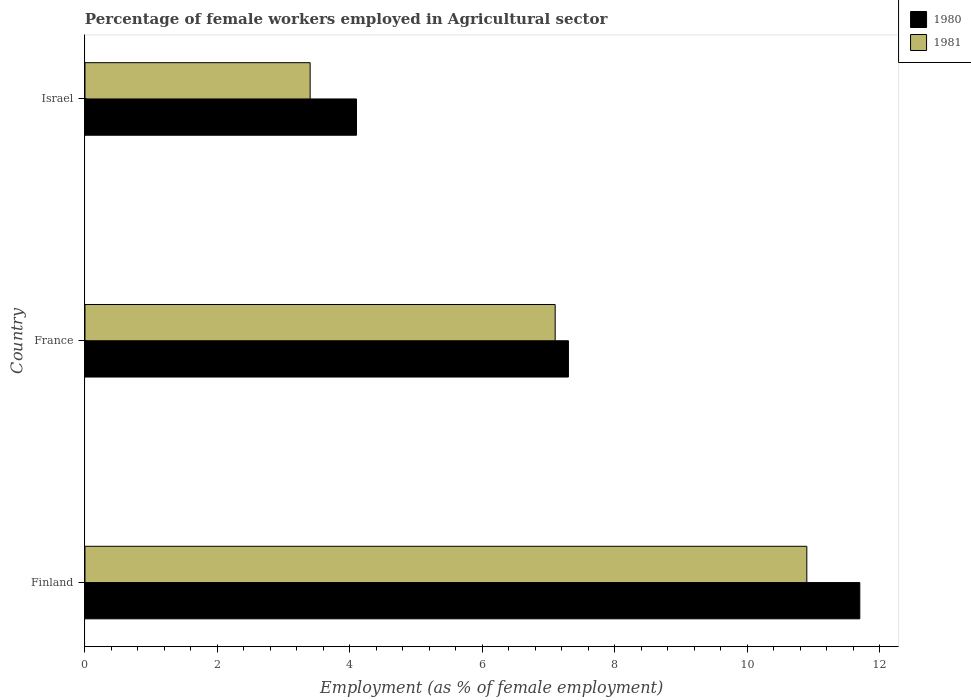How many different coloured bars are there?
Provide a succinct answer. 2. Are the number of bars per tick equal to the number of legend labels?
Your response must be concise. Yes. Are the number of bars on each tick of the Y-axis equal?
Your response must be concise. Yes. How many bars are there on the 1st tick from the bottom?
Offer a very short reply. 2. What is the label of the 3rd group of bars from the top?
Your answer should be very brief. Finland. What is the percentage of females employed in Agricultural sector in 1980 in Israel?
Your answer should be very brief. 4.1. Across all countries, what is the maximum percentage of females employed in Agricultural sector in 1981?
Provide a short and direct response. 10.9. Across all countries, what is the minimum percentage of females employed in Agricultural sector in 1980?
Make the answer very short. 4.1. In which country was the percentage of females employed in Agricultural sector in 1980 minimum?
Ensure brevity in your answer.  Israel. What is the total percentage of females employed in Agricultural sector in 1980 in the graph?
Your response must be concise. 23.1. What is the difference between the percentage of females employed in Agricultural sector in 1981 in France and that in Israel?
Your answer should be very brief. 3.7. What is the difference between the percentage of females employed in Agricultural sector in 1980 in Finland and the percentage of females employed in Agricultural sector in 1981 in Israel?
Your response must be concise. 8.3. What is the average percentage of females employed in Agricultural sector in 1980 per country?
Offer a very short reply. 7.7. What is the difference between the percentage of females employed in Agricultural sector in 1980 and percentage of females employed in Agricultural sector in 1981 in Finland?
Offer a very short reply. 0.8. In how many countries, is the percentage of females employed in Agricultural sector in 1980 greater than 10 %?
Give a very brief answer. 1. What is the ratio of the percentage of females employed in Agricultural sector in 1981 in Finland to that in France?
Your answer should be compact. 1.54. Is the difference between the percentage of females employed in Agricultural sector in 1980 in France and Israel greater than the difference between the percentage of females employed in Agricultural sector in 1981 in France and Israel?
Make the answer very short. No. What is the difference between the highest and the second highest percentage of females employed in Agricultural sector in 1981?
Offer a terse response. 3.8. What is the difference between the highest and the lowest percentage of females employed in Agricultural sector in 1981?
Your response must be concise. 7.5. What does the 1st bar from the top in Israel represents?
Offer a terse response. 1981. What does the 1st bar from the bottom in Israel represents?
Ensure brevity in your answer.  1980. How many countries are there in the graph?
Your answer should be compact. 3. Are the values on the major ticks of X-axis written in scientific E-notation?
Provide a short and direct response. No. Where does the legend appear in the graph?
Ensure brevity in your answer.  Top right. How many legend labels are there?
Offer a terse response. 2. What is the title of the graph?
Provide a short and direct response. Percentage of female workers employed in Agricultural sector. Does "1996" appear as one of the legend labels in the graph?
Your answer should be very brief. No. What is the label or title of the X-axis?
Your response must be concise. Employment (as % of female employment). What is the Employment (as % of female employment) of 1980 in Finland?
Your answer should be very brief. 11.7. What is the Employment (as % of female employment) in 1981 in Finland?
Offer a terse response. 10.9. What is the Employment (as % of female employment) in 1980 in France?
Provide a succinct answer. 7.3. What is the Employment (as % of female employment) in 1981 in France?
Your answer should be very brief. 7.1. What is the Employment (as % of female employment) in 1980 in Israel?
Make the answer very short. 4.1. What is the Employment (as % of female employment) in 1981 in Israel?
Give a very brief answer. 3.4. Across all countries, what is the maximum Employment (as % of female employment) in 1980?
Your answer should be very brief. 11.7. Across all countries, what is the maximum Employment (as % of female employment) of 1981?
Your response must be concise. 10.9. Across all countries, what is the minimum Employment (as % of female employment) in 1980?
Offer a very short reply. 4.1. Across all countries, what is the minimum Employment (as % of female employment) of 1981?
Provide a short and direct response. 3.4. What is the total Employment (as % of female employment) of 1980 in the graph?
Provide a short and direct response. 23.1. What is the total Employment (as % of female employment) of 1981 in the graph?
Offer a terse response. 21.4. What is the difference between the Employment (as % of female employment) of 1981 in France and that in Israel?
Offer a very short reply. 3.7. What is the difference between the Employment (as % of female employment) in 1980 in Finland and the Employment (as % of female employment) in 1981 in France?
Keep it short and to the point. 4.6. What is the difference between the Employment (as % of female employment) in 1980 in Finland and the Employment (as % of female employment) in 1981 in Israel?
Ensure brevity in your answer.  8.3. What is the average Employment (as % of female employment) in 1981 per country?
Provide a short and direct response. 7.13. What is the ratio of the Employment (as % of female employment) in 1980 in Finland to that in France?
Offer a terse response. 1.6. What is the ratio of the Employment (as % of female employment) in 1981 in Finland to that in France?
Your answer should be very brief. 1.54. What is the ratio of the Employment (as % of female employment) of 1980 in Finland to that in Israel?
Your answer should be very brief. 2.85. What is the ratio of the Employment (as % of female employment) in 1981 in Finland to that in Israel?
Make the answer very short. 3.21. What is the ratio of the Employment (as % of female employment) in 1980 in France to that in Israel?
Your answer should be compact. 1.78. What is the ratio of the Employment (as % of female employment) of 1981 in France to that in Israel?
Ensure brevity in your answer.  2.09. What is the difference between the highest and the lowest Employment (as % of female employment) of 1980?
Offer a very short reply. 7.6. 